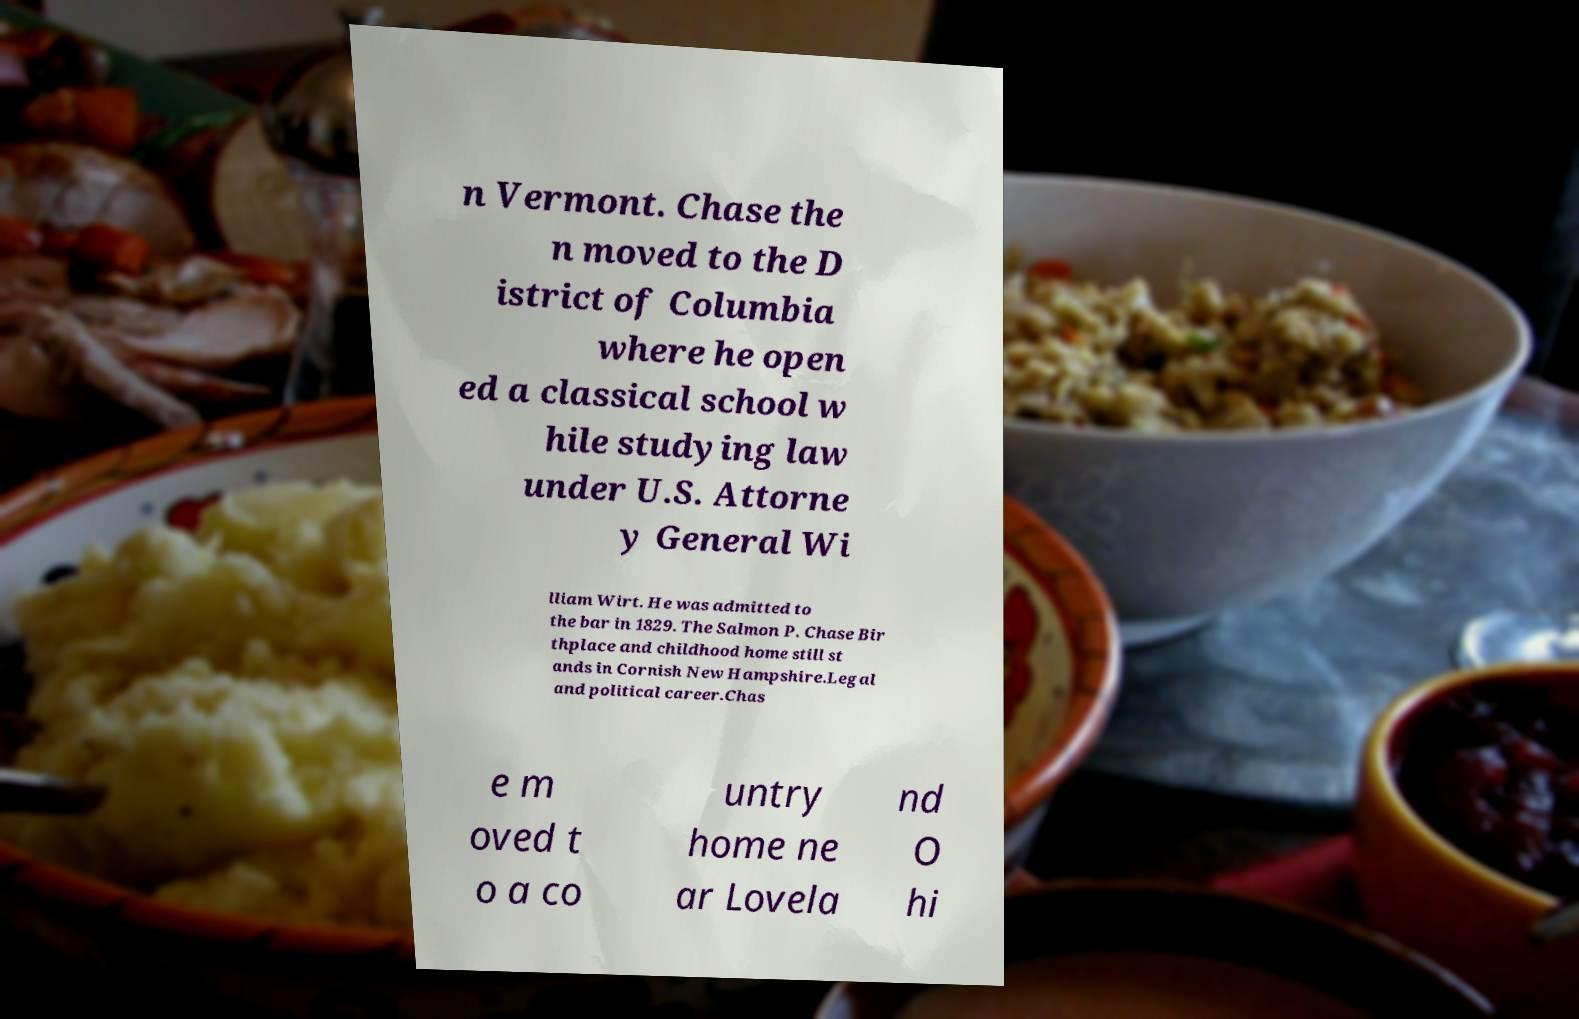Could you assist in decoding the text presented in this image and type it out clearly? n Vermont. Chase the n moved to the D istrict of Columbia where he open ed a classical school w hile studying law under U.S. Attorne y General Wi lliam Wirt. He was admitted to the bar in 1829. The Salmon P. Chase Bir thplace and childhood home still st ands in Cornish New Hampshire.Legal and political career.Chas e m oved t o a co untry home ne ar Lovela nd O hi 